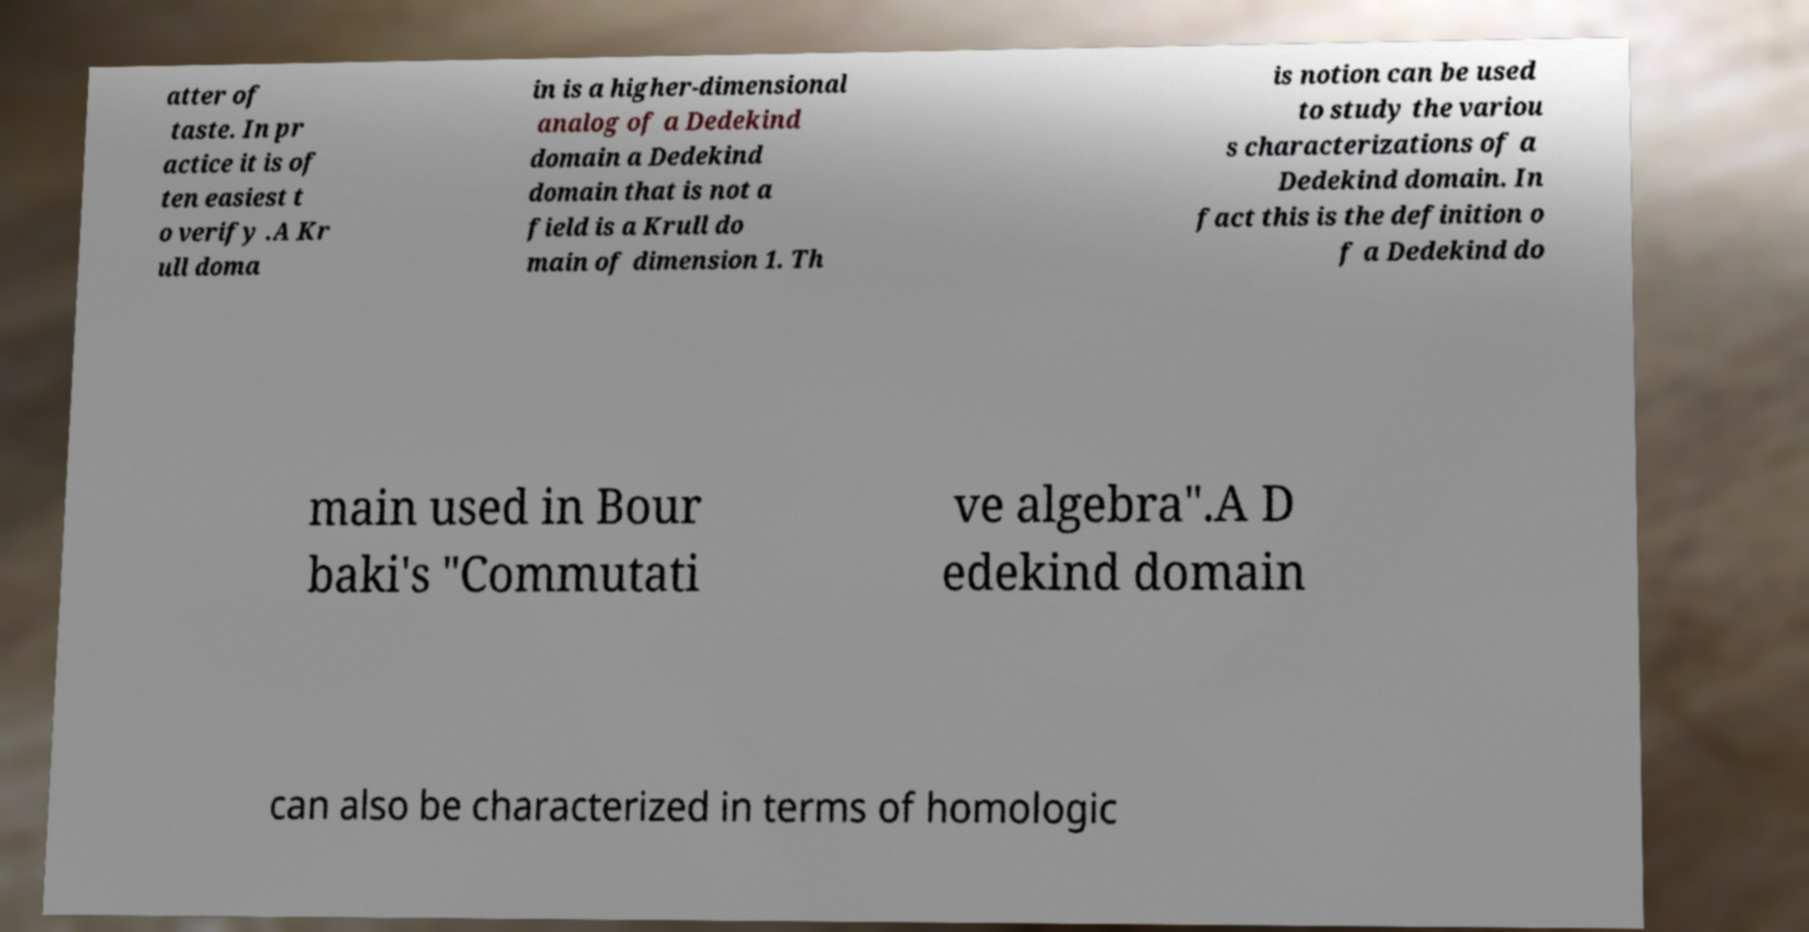I need the written content from this picture converted into text. Can you do that? atter of taste. In pr actice it is of ten easiest t o verify .A Kr ull doma in is a higher-dimensional analog of a Dedekind domain a Dedekind domain that is not a field is a Krull do main of dimension 1. Th is notion can be used to study the variou s characterizations of a Dedekind domain. In fact this is the definition o f a Dedekind do main used in Bour baki's "Commutati ve algebra".A D edekind domain can also be characterized in terms of homologic 